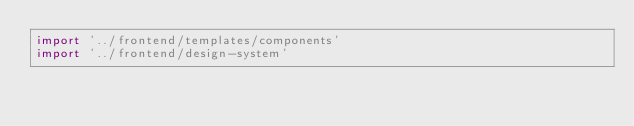<code> <loc_0><loc_0><loc_500><loc_500><_JavaScript_>import '../frontend/templates/components'
import '../frontend/design-system'

</code> 